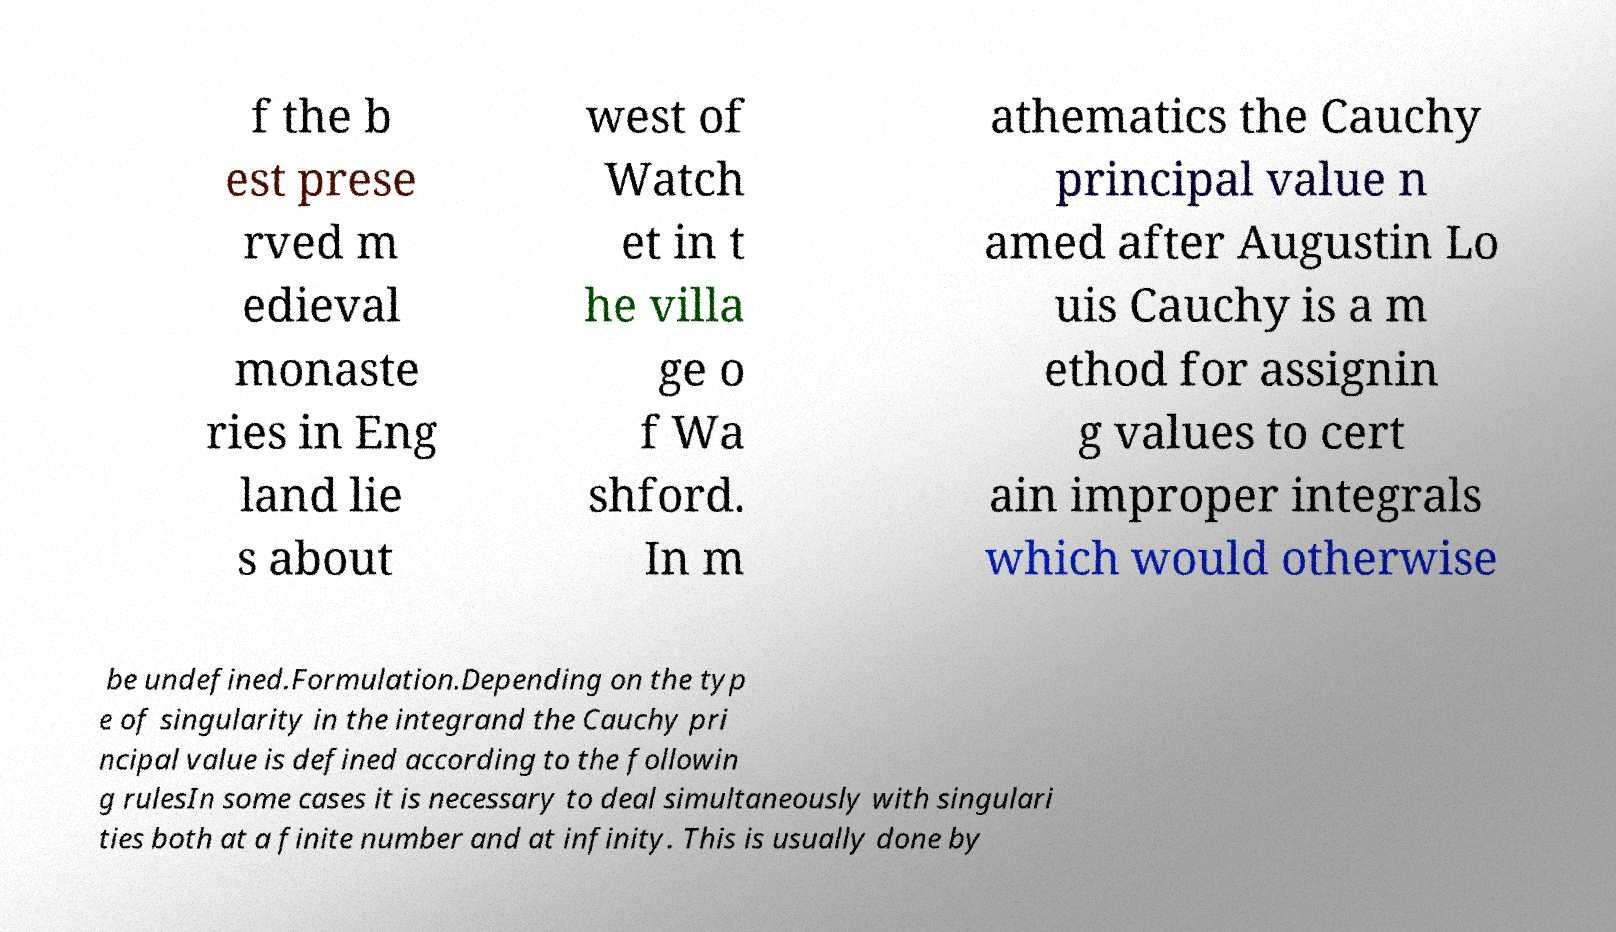For documentation purposes, I need the text within this image transcribed. Could you provide that? f the b est prese rved m edieval monaste ries in Eng land lie s about west of Watch et in t he villa ge o f Wa shford. In m athematics the Cauchy principal value n amed after Augustin Lo uis Cauchy is a m ethod for assignin g values to cert ain improper integrals which would otherwise be undefined.Formulation.Depending on the typ e of singularity in the integrand the Cauchy pri ncipal value is defined according to the followin g rulesIn some cases it is necessary to deal simultaneously with singulari ties both at a finite number and at infinity. This is usually done by 